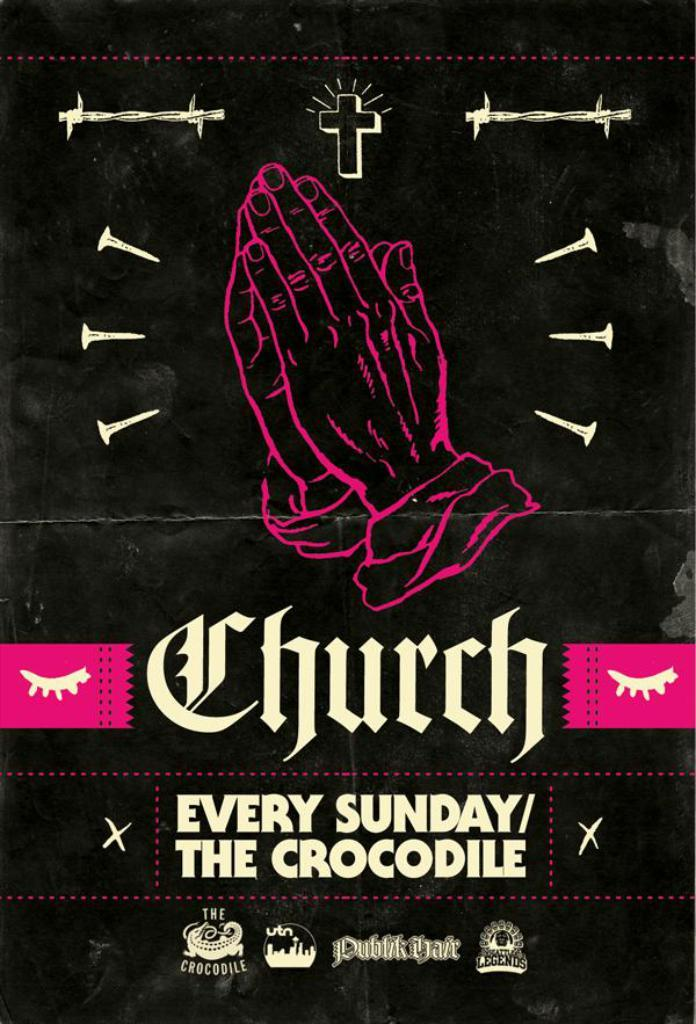<image>
Create a compact narrative representing the image presented. a postor from the play called church every sunday the crocodile 